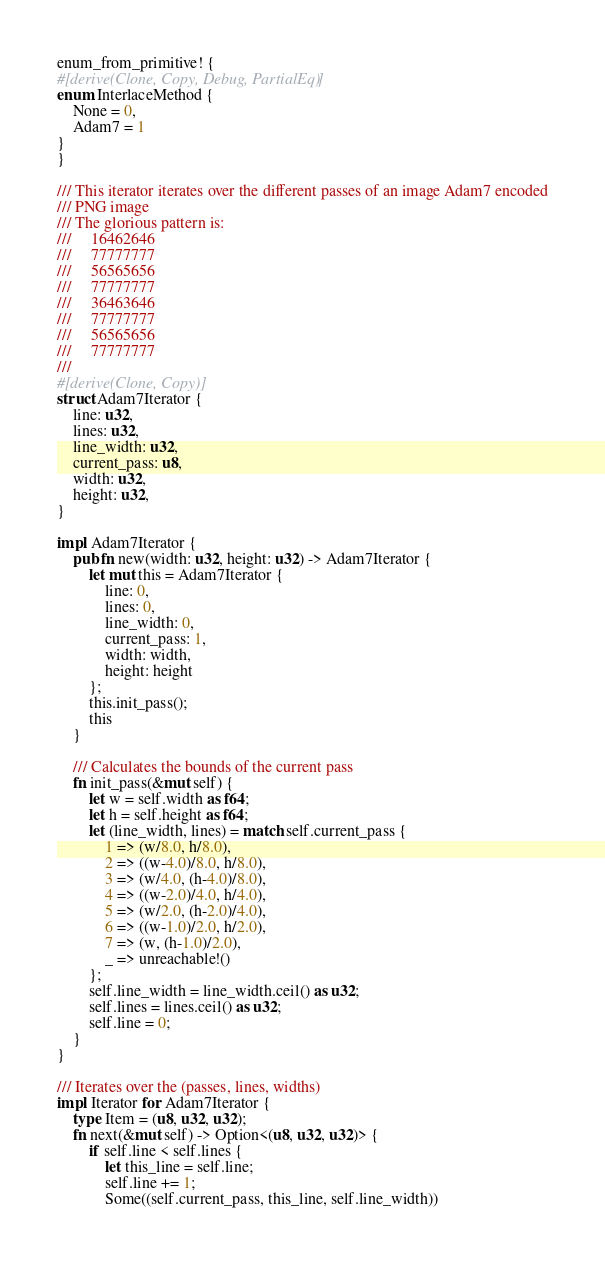<code> <loc_0><loc_0><loc_500><loc_500><_Rust_>
enum_from_primitive! {
#[derive(Clone, Copy, Debug, PartialEq)]
enum InterlaceMethod {
    None = 0,
    Adam7 = 1
}
}

/// This iterator iterates over the different passes of an image Adam7 encoded
/// PNG image
/// The glorious pattern is:
///     16462646
///     77777777
///     56565656
///     77777777
///     36463646
///     77777777
///     56565656
///     77777777
///
#[derive(Clone, Copy)]
struct Adam7Iterator {
    line: u32,
    lines: u32,
    line_width: u32,
    current_pass: u8,
    width: u32,
    height: u32,
}

impl Adam7Iterator {
    pub fn new(width: u32, height: u32) -> Adam7Iterator {
        let mut this = Adam7Iterator {
            line: 0,
            lines: 0,
            line_width: 0,
            current_pass: 1,
            width: width,
            height: height
        };
        this.init_pass();
        this
    }

    /// Calculates the bounds of the current pass
    fn init_pass(&mut self) {
        let w = self.width as f64;
        let h = self.height as f64;
        let (line_width, lines) = match self.current_pass {
            1 => (w/8.0, h/8.0),
            2 => ((w-4.0)/8.0, h/8.0),
            3 => (w/4.0, (h-4.0)/8.0),
            4 => ((w-2.0)/4.0, h/4.0),
            5 => (w/2.0, (h-2.0)/4.0),
            6 => ((w-1.0)/2.0, h/2.0),
            7 => (w, (h-1.0)/2.0),
            _ => unreachable!()
        };
        self.line_width = line_width.ceil() as u32;
        self.lines = lines.ceil() as u32;
        self.line = 0;
    }
}

/// Iterates over the (passes, lines, widths)
impl Iterator for Adam7Iterator {
    type Item = (u8, u32, u32);
    fn next(&mut self) -> Option<(u8, u32, u32)> {
        if self.line < self.lines {
            let this_line = self.line;
            self.line += 1;
            Some((self.current_pass, this_line, self.line_width))</code> 